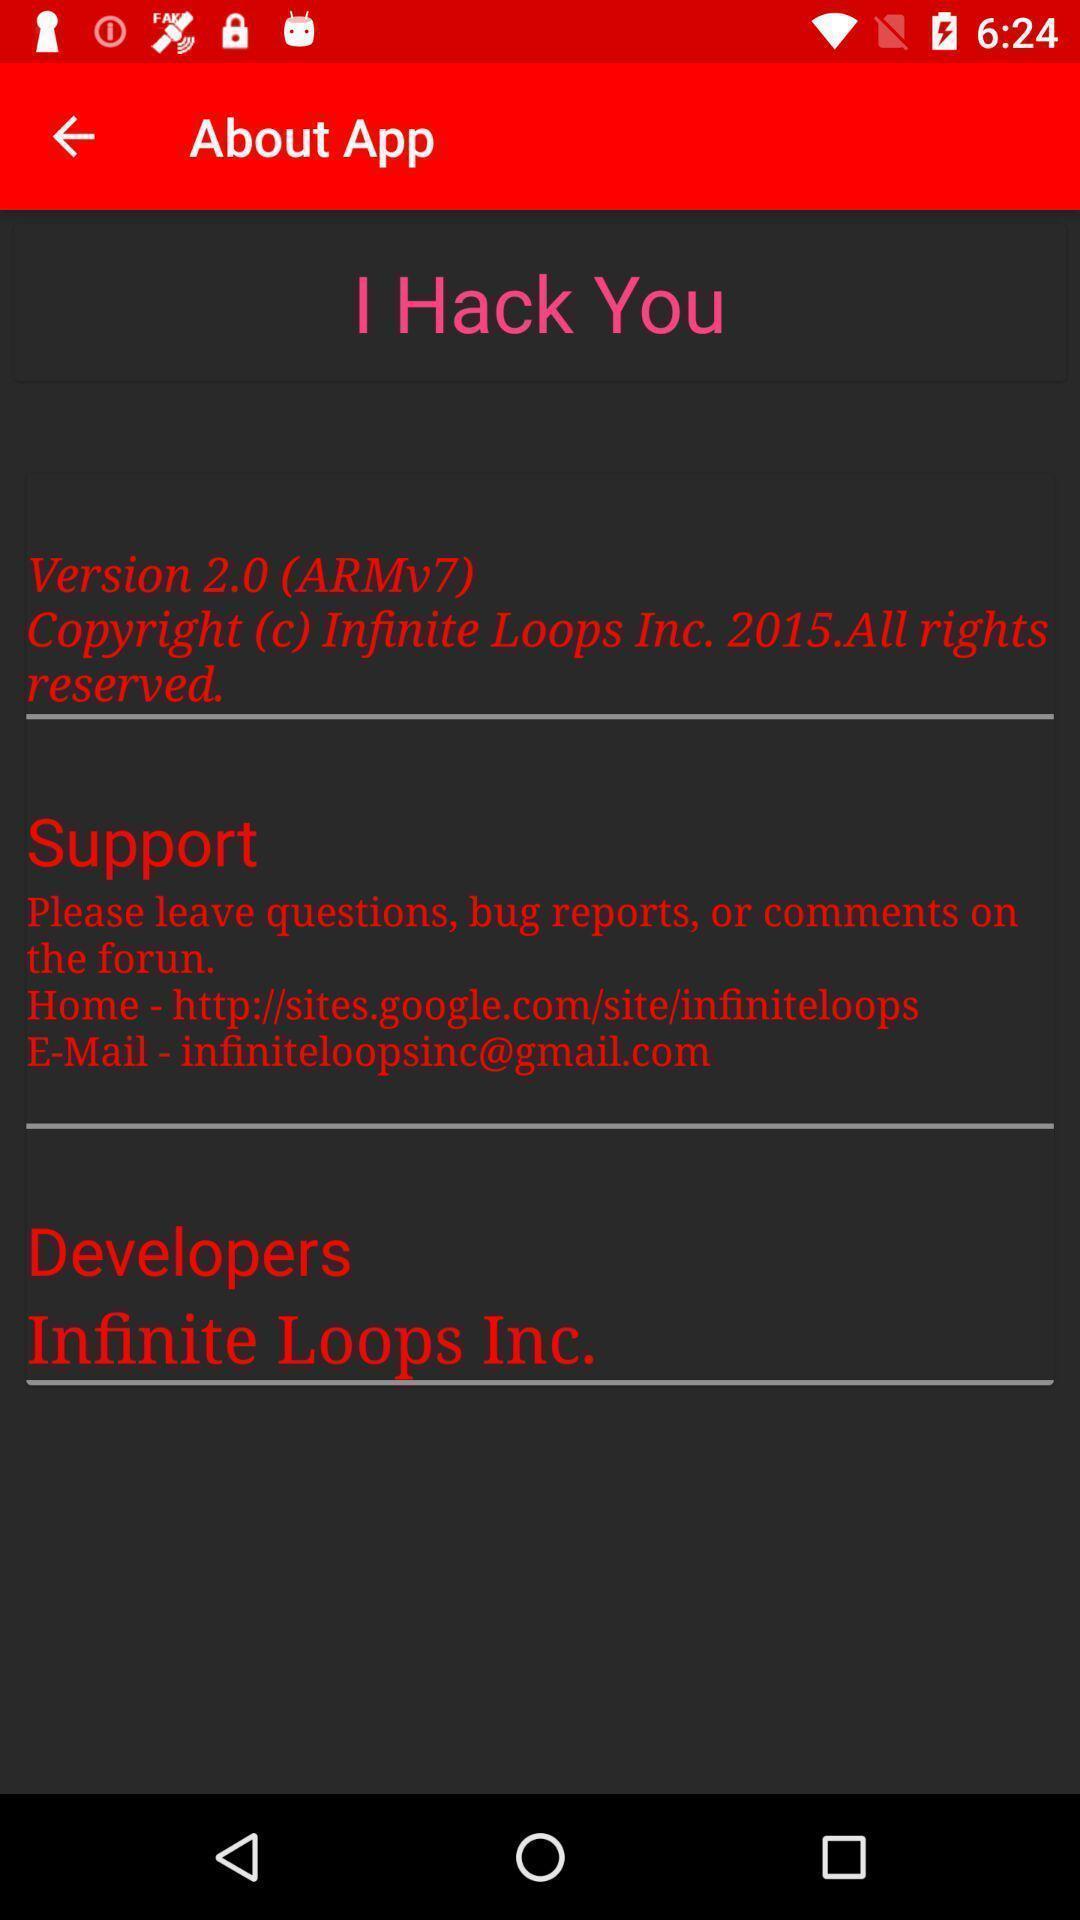Tell me about the visual elements in this screen capture. Page displaying information about the app. 